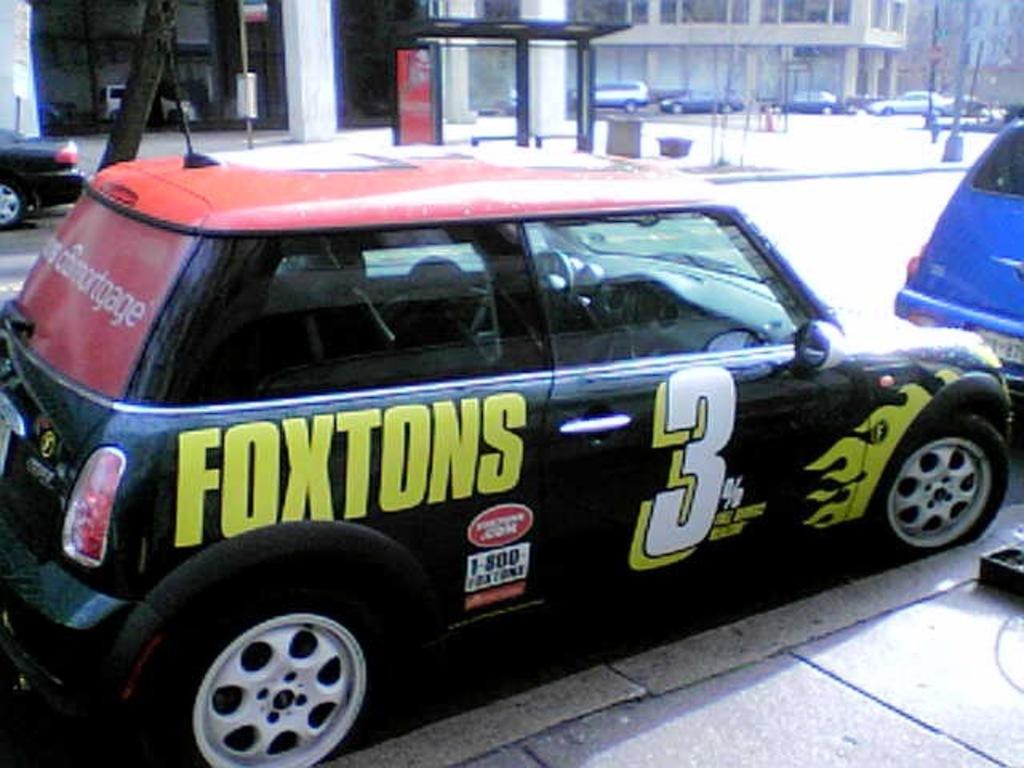Please provide a concise description of this image. In this picture we can see vehicles on the road and in the background we can see buildings. 